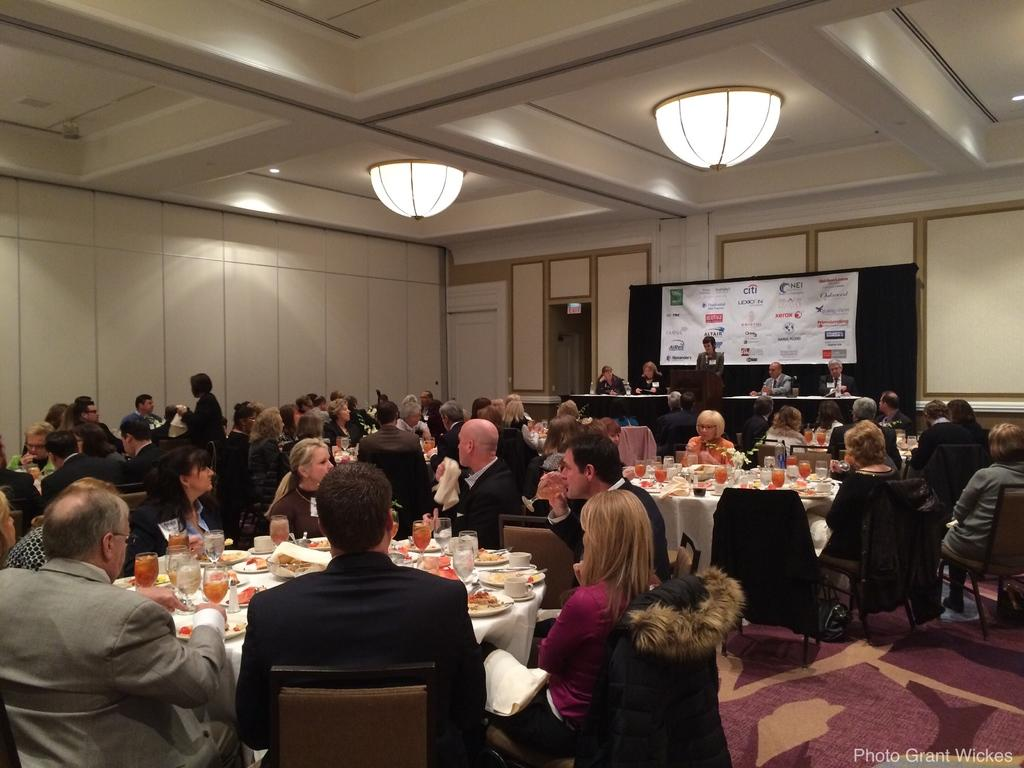What are the people in the image doing? There are persons sitting on chairs in the image, suggesting they might be engaged in a meal or gathering. What can be seen on the table in the image? There are food items and drinks on the table in the image. Can you describe the person standing in the image? There is a person standing in the image, but their specific actions or appearance cannot be determined from the provided facts. What is the purpose of the banner in the image? The banner with text in the image might be used for conveying information or a message to the people present. What type of knife is being used to invent a new shade in the image? There is no knife, invention, or shade present in the image. 